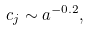Convert formula to latex. <formula><loc_0><loc_0><loc_500><loc_500>c _ { j } \sim a ^ { - 0 . 2 } ,</formula> 